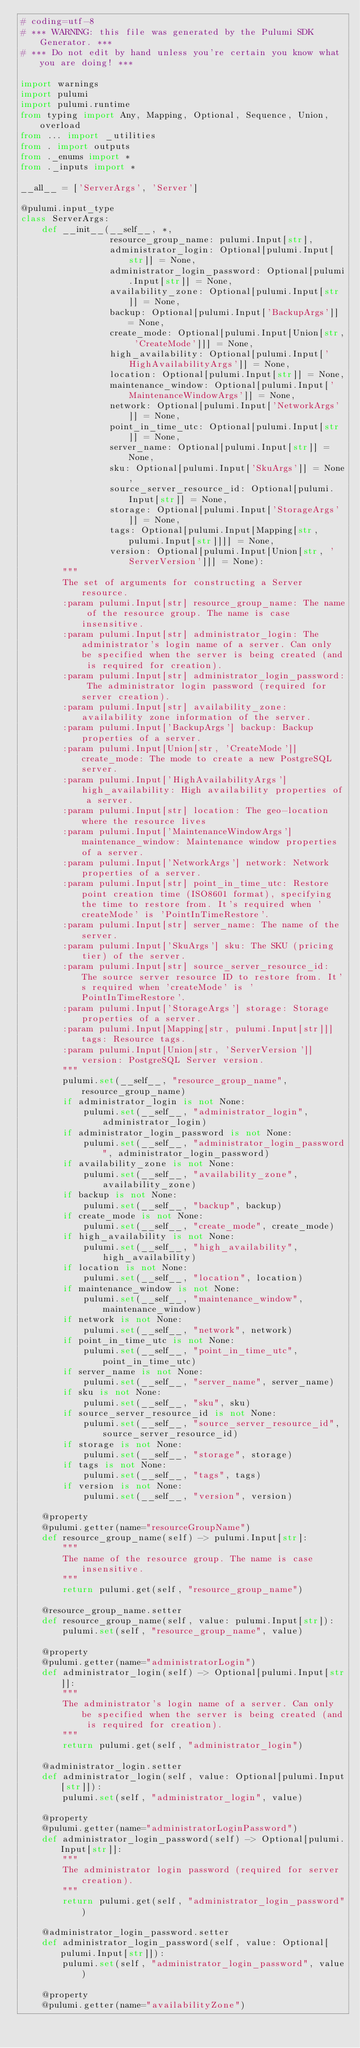Convert code to text. <code><loc_0><loc_0><loc_500><loc_500><_Python_># coding=utf-8
# *** WARNING: this file was generated by the Pulumi SDK Generator. ***
# *** Do not edit by hand unless you're certain you know what you are doing! ***

import warnings
import pulumi
import pulumi.runtime
from typing import Any, Mapping, Optional, Sequence, Union, overload
from ... import _utilities
from . import outputs
from ._enums import *
from ._inputs import *

__all__ = ['ServerArgs', 'Server']

@pulumi.input_type
class ServerArgs:
    def __init__(__self__, *,
                 resource_group_name: pulumi.Input[str],
                 administrator_login: Optional[pulumi.Input[str]] = None,
                 administrator_login_password: Optional[pulumi.Input[str]] = None,
                 availability_zone: Optional[pulumi.Input[str]] = None,
                 backup: Optional[pulumi.Input['BackupArgs']] = None,
                 create_mode: Optional[pulumi.Input[Union[str, 'CreateMode']]] = None,
                 high_availability: Optional[pulumi.Input['HighAvailabilityArgs']] = None,
                 location: Optional[pulumi.Input[str]] = None,
                 maintenance_window: Optional[pulumi.Input['MaintenanceWindowArgs']] = None,
                 network: Optional[pulumi.Input['NetworkArgs']] = None,
                 point_in_time_utc: Optional[pulumi.Input[str]] = None,
                 server_name: Optional[pulumi.Input[str]] = None,
                 sku: Optional[pulumi.Input['SkuArgs']] = None,
                 source_server_resource_id: Optional[pulumi.Input[str]] = None,
                 storage: Optional[pulumi.Input['StorageArgs']] = None,
                 tags: Optional[pulumi.Input[Mapping[str, pulumi.Input[str]]]] = None,
                 version: Optional[pulumi.Input[Union[str, 'ServerVersion']]] = None):
        """
        The set of arguments for constructing a Server resource.
        :param pulumi.Input[str] resource_group_name: The name of the resource group. The name is case insensitive.
        :param pulumi.Input[str] administrator_login: The administrator's login name of a server. Can only be specified when the server is being created (and is required for creation).
        :param pulumi.Input[str] administrator_login_password: The administrator login password (required for server creation).
        :param pulumi.Input[str] availability_zone: availability zone information of the server.
        :param pulumi.Input['BackupArgs'] backup: Backup properties of a server.
        :param pulumi.Input[Union[str, 'CreateMode']] create_mode: The mode to create a new PostgreSQL server.
        :param pulumi.Input['HighAvailabilityArgs'] high_availability: High availability properties of a server.
        :param pulumi.Input[str] location: The geo-location where the resource lives
        :param pulumi.Input['MaintenanceWindowArgs'] maintenance_window: Maintenance window properties of a server.
        :param pulumi.Input['NetworkArgs'] network: Network properties of a server.
        :param pulumi.Input[str] point_in_time_utc: Restore point creation time (ISO8601 format), specifying the time to restore from. It's required when 'createMode' is 'PointInTimeRestore'.
        :param pulumi.Input[str] server_name: The name of the server.
        :param pulumi.Input['SkuArgs'] sku: The SKU (pricing tier) of the server.
        :param pulumi.Input[str] source_server_resource_id: The source server resource ID to restore from. It's required when 'createMode' is 'PointInTimeRestore'.
        :param pulumi.Input['StorageArgs'] storage: Storage properties of a server.
        :param pulumi.Input[Mapping[str, pulumi.Input[str]]] tags: Resource tags.
        :param pulumi.Input[Union[str, 'ServerVersion']] version: PostgreSQL Server version.
        """
        pulumi.set(__self__, "resource_group_name", resource_group_name)
        if administrator_login is not None:
            pulumi.set(__self__, "administrator_login", administrator_login)
        if administrator_login_password is not None:
            pulumi.set(__self__, "administrator_login_password", administrator_login_password)
        if availability_zone is not None:
            pulumi.set(__self__, "availability_zone", availability_zone)
        if backup is not None:
            pulumi.set(__self__, "backup", backup)
        if create_mode is not None:
            pulumi.set(__self__, "create_mode", create_mode)
        if high_availability is not None:
            pulumi.set(__self__, "high_availability", high_availability)
        if location is not None:
            pulumi.set(__self__, "location", location)
        if maintenance_window is not None:
            pulumi.set(__self__, "maintenance_window", maintenance_window)
        if network is not None:
            pulumi.set(__self__, "network", network)
        if point_in_time_utc is not None:
            pulumi.set(__self__, "point_in_time_utc", point_in_time_utc)
        if server_name is not None:
            pulumi.set(__self__, "server_name", server_name)
        if sku is not None:
            pulumi.set(__self__, "sku", sku)
        if source_server_resource_id is not None:
            pulumi.set(__self__, "source_server_resource_id", source_server_resource_id)
        if storage is not None:
            pulumi.set(__self__, "storage", storage)
        if tags is not None:
            pulumi.set(__self__, "tags", tags)
        if version is not None:
            pulumi.set(__self__, "version", version)

    @property
    @pulumi.getter(name="resourceGroupName")
    def resource_group_name(self) -> pulumi.Input[str]:
        """
        The name of the resource group. The name is case insensitive.
        """
        return pulumi.get(self, "resource_group_name")

    @resource_group_name.setter
    def resource_group_name(self, value: pulumi.Input[str]):
        pulumi.set(self, "resource_group_name", value)

    @property
    @pulumi.getter(name="administratorLogin")
    def administrator_login(self) -> Optional[pulumi.Input[str]]:
        """
        The administrator's login name of a server. Can only be specified when the server is being created (and is required for creation).
        """
        return pulumi.get(self, "administrator_login")

    @administrator_login.setter
    def administrator_login(self, value: Optional[pulumi.Input[str]]):
        pulumi.set(self, "administrator_login", value)

    @property
    @pulumi.getter(name="administratorLoginPassword")
    def administrator_login_password(self) -> Optional[pulumi.Input[str]]:
        """
        The administrator login password (required for server creation).
        """
        return pulumi.get(self, "administrator_login_password")

    @administrator_login_password.setter
    def administrator_login_password(self, value: Optional[pulumi.Input[str]]):
        pulumi.set(self, "administrator_login_password", value)

    @property
    @pulumi.getter(name="availabilityZone")</code> 